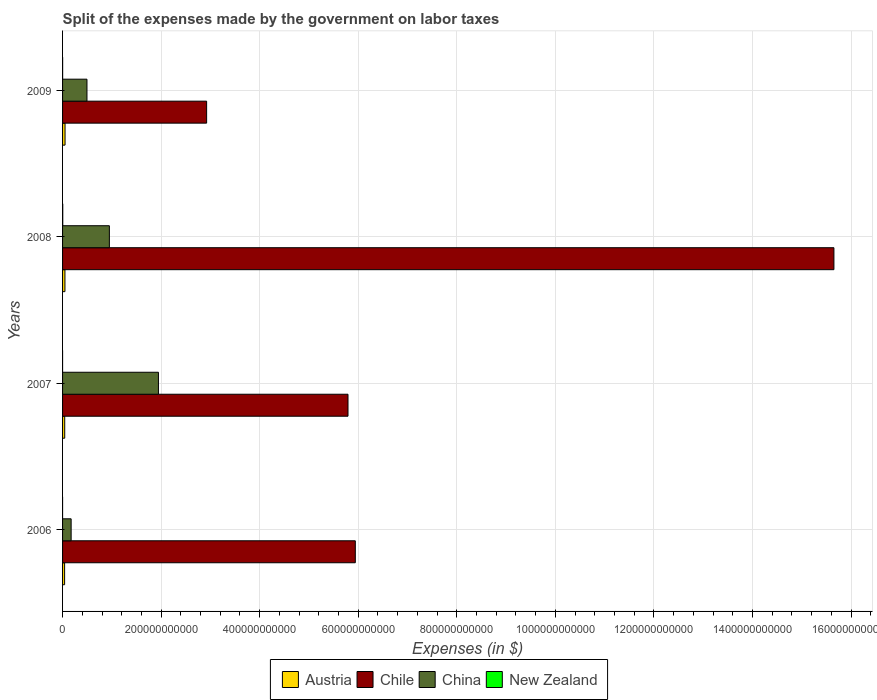How many different coloured bars are there?
Your answer should be very brief. 4. Are the number of bars per tick equal to the number of legend labels?
Your answer should be very brief. Yes. Are the number of bars on each tick of the Y-axis equal?
Your answer should be very brief. Yes. In how many cases, is the number of bars for a given year not equal to the number of legend labels?
Your answer should be compact. 0. What is the expenses made by the government on labor taxes in Chile in 2007?
Provide a short and direct response. 5.79e+11. Across all years, what is the maximum expenses made by the government on labor taxes in China?
Your answer should be very brief. 1.95e+11. Across all years, what is the minimum expenses made by the government on labor taxes in China?
Your answer should be very brief. 1.74e+1. In which year was the expenses made by the government on labor taxes in Chile maximum?
Your response must be concise. 2008. What is the total expenses made by the government on labor taxes in China in the graph?
Keep it short and to the point. 3.56e+11. What is the difference between the expenses made by the government on labor taxes in Austria in 2007 and that in 2008?
Provide a short and direct response. -4.27e+08. What is the difference between the expenses made by the government on labor taxes in Austria in 2008 and the expenses made by the government on labor taxes in Chile in 2007?
Provide a short and direct response. -5.74e+11. What is the average expenses made by the government on labor taxes in Austria per year?
Make the answer very short. 4.59e+09. In the year 2007, what is the difference between the expenses made by the government on labor taxes in Austria and expenses made by the government on labor taxes in China?
Your answer should be very brief. -1.90e+11. In how many years, is the expenses made by the government on labor taxes in China greater than 1440000000000 $?
Your response must be concise. 0. What is the ratio of the expenses made by the government on labor taxes in New Zealand in 2006 to that in 2008?
Offer a very short reply. 0.01. Is the difference between the expenses made by the government on labor taxes in Austria in 2008 and 2009 greater than the difference between the expenses made by the government on labor taxes in China in 2008 and 2009?
Keep it short and to the point. No. What is the difference between the highest and the second highest expenses made by the government on labor taxes in Austria?
Offer a terse response. 2.13e+08. What is the difference between the highest and the lowest expenses made by the government on labor taxes in Chile?
Give a very brief answer. 1.27e+12. Is the sum of the expenses made by the government on labor taxes in Chile in 2008 and 2009 greater than the maximum expenses made by the government on labor taxes in New Zealand across all years?
Give a very brief answer. Yes. Is it the case that in every year, the sum of the expenses made by the government on labor taxes in Austria and expenses made by the government on labor taxes in Chile is greater than the sum of expenses made by the government on labor taxes in New Zealand and expenses made by the government on labor taxes in China?
Give a very brief answer. Yes. What does the 4th bar from the top in 2007 represents?
Give a very brief answer. Austria. Is it the case that in every year, the sum of the expenses made by the government on labor taxes in Chile and expenses made by the government on labor taxes in China is greater than the expenses made by the government on labor taxes in New Zealand?
Provide a succinct answer. Yes. How many bars are there?
Your answer should be compact. 16. Are all the bars in the graph horizontal?
Your answer should be compact. Yes. How many years are there in the graph?
Offer a very short reply. 4. What is the difference between two consecutive major ticks on the X-axis?
Provide a succinct answer. 2.00e+11. Are the values on the major ticks of X-axis written in scientific E-notation?
Provide a short and direct response. No. Where does the legend appear in the graph?
Keep it short and to the point. Bottom center. How many legend labels are there?
Make the answer very short. 4. How are the legend labels stacked?
Make the answer very short. Horizontal. What is the title of the graph?
Ensure brevity in your answer.  Split of the expenses made by the government on labor taxes. Does "Congo (Republic)" appear as one of the legend labels in the graph?
Provide a short and direct response. No. What is the label or title of the X-axis?
Your answer should be compact. Expenses (in $). What is the label or title of the Y-axis?
Your answer should be compact. Years. What is the Expenses (in $) of Austria in 2006?
Make the answer very short. 4.15e+09. What is the Expenses (in $) of Chile in 2006?
Your response must be concise. 5.94e+11. What is the Expenses (in $) of China in 2006?
Keep it short and to the point. 1.74e+1. What is the Expenses (in $) in New Zealand in 2006?
Keep it short and to the point. 3.00e+06. What is the Expenses (in $) in Austria in 2007?
Ensure brevity in your answer.  4.38e+09. What is the Expenses (in $) of Chile in 2007?
Provide a succinct answer. 5.79e+11. What is the Expenses (in $) in China in 2007?
Give a very brief answer. 1.95e+11. What is the Expenses (in $) of Austria in 2008?
Ensure brevity in your answer.  4.81e+09. What is the Expenses (in $) of Chile in 2008?
Your response must be concise. 1.57e+12. What is the Expenses (in $) of China in 2008?
Provide a short and direct response. 9.50e+1. What is the Expenses (in $) in New Zealand in 2008?
Provide a succinct answer. 3.75e+08. What is the Expenses (in $) of Austria in 2009?
Offer a terse response. 5.02e+09. What is the Expenses (in $) in Chile in 2009?
Your response must be concise. 2.92e+11. What is the Expenses (in $) in China in 2009?
Provide a short and direct response. 4.95e+1. What is the Expenses (in $) of New Zealand in 2009?
Give a very brief answer. 1.28e+08. Across all years, what is the maximum Expenses (in $) in Austria?
Make the answer very short. 5.02e+09. Across all years, what is the maximum Expenses (in $) of Chile?
Offer a very short reply. 1.57e+12. Across all years, what is the maximum Expenses (in $) of China?
Your answer should be very brief. 1.95e+11. Across all years, what is the maximum Expenses (in $) in New Zealand?
Your answer should be very brief. 3.75e+08. Across all years, what is the minimum Expenses (in $) in Austria?
Give a very brief answer. 4.15e+09. Across all years, what is the minimum Expenses (in $) of Chile?
Your answer should be very brief. 2.92e+11. Across all years, what is the minimum Expenses (in $) in China?
Provide a short and direct response. 1.74e+1. What is the total Expenses (in $) of Austria in the graph?
Your answer should be compact. 1.84e+1. What is the total Expenses (in $) of Chile in the graph?
Give a very brief answer. 3.03e+12. What is the total Expenses (in $) in China in the graph?
Provide a short and direct response. 3.56e+11. What is the total Expenses (in $) in New Zealand in the graph?
Provide a succinct answer. 5.08e+08. What is the difference between the Expenses (in $) in Austria in 2006 and that in 2007?
Your answer should be very brief. -2.29e+08. What is the difference between the Expenses (in $) in Chile in 2006 and that in 2007?
Ensure brevity in your answer.  1.48e+1. What is the difference between the Expenses (in $) in China in 2006 and that in 2007?
Your response must be concise. -1.77e+11. What is the difference between the Expenses (in $) in New Zealand in 2006 and that in 2007?
Your answer should be very brief. 1.00e+06. What is the difference between the Expenses (in $) in Austria in 2006 and that in 2008?
Provide a succinct answer. -6.56e+08. What is the difference between the Expenses (in $) of Chile in 2006 and that in 2008?
Offer a terse response. -9.71e+11. What is the difference between the Expenses (in $) in China in 2006 and that in 2008?
Ensure brevity in your answer.  -7.76e+1. What is the difference between the Expenses (in $) in New Zealand in 2006 and that in 2008?
Offer a very short reply. -3.72e+08. What is the difference between the Expenses (in $) of Austria in 2006 and that in 2009?
Ensure brevity in your answer.  -8.69e+08. What is the difference between the Expenses (in $) in Chile in 2006 and that in 2009?
Provide a succinct answer. 3.02e+11. What is the difference between the Expenses (in $) of China in 2006 and that in 2009?
Your response must be concise. -3.21e+1. What is the difference between the Expenses (in $) of New Zealand in 2006 and that in 2009?
Give a very brief answer. -1.25e+08. What is the difference between the Expenses (in $) in Austria in 2007 and that in 2008?
Your response must be concise. -4.27e+08. What is the difference between the Expenses (in $) in Chile in 2007 and that in 2008?
Your answer should be compact. -9.86e+11. What is the difference between the Expenses (in $) of China in 2007 and that in 2008?
Keep it short and to the point. 9.95e+1. What is the difference between the Expenses (in $) of New Zealand in 2007 and that in 2008?
Your answer should be compact. -3.73e+08. What is the difference between the Expenses (in $) in Austria in 2007 and that in 2009?
Your response must be concise. -6.40e+08. What is the difference between the Expenses (in $) in Chile in 2007 and that in 2009?
Your answer should be compact. 2.87e+11. What is the difference between the Expenses (in $) in China in 2007 and that in 2009?
Offer a terse response. 1.45e+11. What is the difference between the Expenses (in $) in New Zealand in 2007 and that in 2009?
Provide a short and direct response. -1.26e+08. What is the difference between the Expenses (in $) of Austria in 2008 and that in 2009?
Make the answer very short. -2.13e+08. What is the difference between the Expenses (in $) in Chile in 2008 and that in 2009?
Your response must be concise. 1.27e+12. What is the difference between the Expenses (in $) in China in 2008 and that in 2009?
Offer a very short reply. 4.55e+1. What is the difference between the Expenses (in $) of New Zealand in 2008 and that in 2009?
Make the answer very short. 2.47e+08. What is the difference between the Expenses (in $) of Austria in 2006 and the Expenses (in $) of Chile in 2007?
Provide a short and direct response. -5.75e+11. What is the difference between the Expenses (in $) in Austria in 2006 and the Expenses (in $) in China in 2007?
Offer a terse response. -1.90e+11. What is the difference between the Expenses (in $) in Austria in 2006 and the Expenses (in $) in New Zealand in 2007?
Keep it short and to the point. 4.15e+09. What is the difference between the Expenses (in $) of Chile in 2006 and the Expenses (in $) of China in 2007?
Provide a succinct answer. 3.99e+11. What is the difference between the Expenses (in $) in Chile in 2006 and the Expenses (in $) in New Zealand in 2007?
Keep it short and to the point. 5.94e+11. What is the difference between the Expenses (in $) in China in 2006 and the Expenses (in $) in New Zealand in 2007?
Offer a terse response. 1.74e+1. What is the difference between the Expenses (in $) in Austria in 2006 and the Expenses (in $) in Chile in 2008?
Give a very brief answer. -1.56e+12. What is the difference between the Expenses (in $) of Austria in 2006 and the Expenses (in $) of China in 2008?
Make the answer very short. -9.08e+1. What is the difference between the Expenses (in $) of Austria in 2006 and the Expenses (in $) of New Zealand in 2008?
Keep it short and to the point. 3.78e+09. What is the difference between the Expenses (in $) of Chile in 2006 and the Expenses (in $) of China in 2008?
Ensure brevity in your answer.  4.99e+11. What is the difference between the Expenses (in $) of Chile in 2006 and the Expenses (in $) of New Zealand in 2008?
Make the answer very short. 5.94e+11. What is the difference between the Expenses (in $) of China in 2006 and the Expenses (in $) of New Zealand in 2008?
Provide a short and direct response. 1.70e+1. What is the difference between the Expenses (in $) of Austria in 2006 and the Expenses (in $) of Chile in 2009?
Keep it short and to the point. -2.88e+11. What is the difference between the Expenses (in $) in Austria in 2006 and the Expenses (in $) in China in 2009?
Your response must be concise. -4.54e+1. What is the difference between the Expenses (in $) of Austria in 2006 and the Expenses (in $) of New Zealand in 2009?
Your response must be concise. 4.02e+09. What is the difference between the Expenses (in $) in Chile in 2006 and the Expenses (in $) in China in 2009?
Provide a short and direct response. 5.44e+11. What is the difference between the Expenses (in $) of Chile in 2006 and the Expenses (in $) of New Zealand in 2009?
Your response must be concise. 5.94e+11. What is the difference between the Expenses (in $) of China in 2006 and the Expenses (in $) of New Zealand in 2009?
Your answer should be compact. 1.73e+1. What is the difference between the Expenses (in $) of Austria in 2007 and the Expenses (in $) of Chile in 2008?
Your answer should be very brief. -1.56e+12. What is the difference between the Expenses (in $) of Austria in 2007 and the Expenses (in $) of China in 2008?
Offer a very short reply. -9.06e+1. What is the difference between the Expenses (in $) in Austria in 2007 and the Expenses (in $) in New Zealand in 2008?
Keep it short and to the point. 4.00e+09. What is the difference between the Expenses (in $) of Chile in 2007 and the Expenses (in $) of China in 2008?
Ensure brevity in your answer.  4.84e+11. What is the difference between the Expenses (in $) in Chile in 2007 and the Expenses (in $) in New Zealand in 2008?
Your response must be concise. 5.79e+11. What is the difference between the Expenses (in $) in China in 2007 and the Expenses (in $) in New Zealand in 2008?
Your response must be concise. 1.94e+11. What is the difference between the Expenses (in $) in Austria in 2007 and the Expenses (in $) in Chile in 2009?
Keep it short and to the point. -2.88e+11. What is the difference between the Expenses (in $) in Austria in 2007 and the Expenses (in $) in China in 2009?
Your response must be concise. -4.51e+1. What is the difference between the Expenses (in $) in Austria in 2007 and the Expenses (in $) in New Zealand in 2009?
Ensure brevity in your answer.  4.25e+09. What is the difference between the Expenses (in $) of Chile in 2007 and the Expenses (in $) of China in 2009?
Your answer should be compact. 5.30e+11. What is the difference between the Expenses (in $) of Chile in 2007 and the Expenses (in $) of New Zealand in 2009?
Give a very brief answer. 5.79e+11. What is the difference between the Expenses (in $) in China in 2007 and the Expenses (in $) in New Zealand in 2009?
Provide a short and direct response. 1.94e+11. What is the difference between the Expenses (in $) of Austria in 2008 and the Expenses (in $) of Chile in 2009?
Offer a very short reply. -2.87e+11. What is the difference between the Expenses (in $) of Austria in 2008 and the Expenses (in $) of China in 2009?
Make the answer very short. -4.47e+1. What is the difference between the Expenses (in $) in Austria in 2008 and the Expenses (in $) in New Zealand in 2009?
Offer a terse response. 4.68e+09. What is the difference between the Expenses (in $) in Chile in 2008 and the Expenses (in $) in China in 2009?
Offer a very short reply. 1.52e+12. What is the difference between the Expenses (in $) of Chile in 2008 and the Expenses (in $) of New Zealand in 2009?
Keep it short and to the point. 1.56e+12. What is the difference between the Expenses (in $) of China in 2008 and the Expenses (in $) of New Zealand in 2009?
Give a very brief answer. 9.49e+1. What is the average Expenses (in $) of Austria per year?
Your answer should be compact. 4.59e+09. What is the average Expenses (in $) in Chile per year?
Your response must be concise. 7.58e+11. What is the average Expenses (in $) of China per year?
Keep it short and to the point. 8.91e+1. What is the average Expenses (in $) in New Zealand per year?
Offer a terse response. 1.27e+08. In the year 2006, what is the difference between the Expenses (in $) in Austria and Expenses (in $) in Chile?
Your response must be concise. -5.90e+11. In the year 2006, what is the difference between the Expenses (in $) in Austria and Expenses (in $) in China?
Your answer should be very brief. -1.33e+1. In the year 2006, what is the difference between the Expenses (in $) of Austria and Expenses (in $) of New Zealand?
Give a very brief answer. 4.15e+09. In the year 2006, what is the difference between the Expenses (in $) of Chile and Expenses (in $) of China?
Give a very brief answer. 5.77e+11. In the year 2006, what is the difference between the Expenses (in $) in Chile and Expenses (in $) in New Zealand?
Your answer should be very brief. 5.94e+11. In the year 2006, what is the difference between the Expenses (in $) in China and Expenses (in $) in New Zealand?
Ensure brevity in your answer.  1.74e+1. In the year 2007, what is the difference between the Expenses (in $) of Austria and Expenses (in $) of Chile?
Your answer should be very brief. -5.75e+11. In the year 2007, what is the difference between the Expenses (in $) of Austria and Expenses (in $) of China?
Offer a terse response. -1.90e+11. In the year 2007, what is the difference between the Expenses (in $) of Austria and Expenses (in $) of New Zealand?
Offer a very short reply. 4.38e+09. In the year 2007, what is the difference between the Expenses (in $) in Chile and Expenses (in $) in China?
Provide a succinct answer. 3.85e+11. In the year 2007, what is the difference between the Expenses (in $) of Chile and Expenses (in $) of New Zealand?
Give a very brief answer. 5.79e+11. In the year 2007, what is the difference between the Expenses (in $) of China and Expenses (in $) of New Zealand?
Give a very brief answer. 1.95e+11. In the year 2008, what is the difference between the Expenses (in $) in Austria and Expenses (in $) in Chile?
Provide a short and direct response. -1.56e+12. In the year 2008, what is the difference between the Expenses (in $) in Austria and Expenses (in $) in China?
Provide a succinct answer. -9.02e+1. In the year 2008, what is the difference between the Expenses (in $) of Austria and Expenses (in $) of New Zealand?
Provide a succinct answer. 4.43e+09. In the year 2008, what is the difference between the Expenses (in $) in Chile and Expenses (in $) in China?
Your answer should be very brief. 1.47e+12. In the year 2008, what is the difference between the Expenses (in $) in Chile and Expenses (in $) in New Zealand?
Your answer should be compact. 1.56e+12. In the year 2008, what is the difference between the Expenses (in $) in China and Expenses (in $) in New Zealand?
Make the answer very short. 9.46e+1. In the year 2009, what is the difference between the Expenses (in $) of Austria and Expenses (in $) of Chile?
Provide a succinct answer. -2.87e+11. In the year 2009, what is the difference between the Expenses (in $) in Austria and Expenses (in $) in China?
Offer a terse response. -4.45e+1. In the year 2009, what is the difference between the Expenses (in $) of Austria and Expenses (in $) of New Zealand?
Provide a succinct answer. 4.89e+09. In the year 2009, what is the difference between the Expenses (in $) of Chile and Expenses (in $) of China?
Offer a very short reply. 2.43e+11. In the year 2009, what is the difference between the Expenses (in $) in Chile and Expenses (in $) in New Zealand?
Provide a short and direct response. 2.92e+11. In the year 2009, what is the difference between the Expenses (in $) in China and Expenses (in $) in New Zealand?
Your answer should be compact. 4.94e+1. What is the ratio of the Expenses (in $) of Austria in 2006 to that in 2007?
Offer a terse response. 0.95. What is the ratio of the Expenses (in $) in Chile in 2006 to that in 2007?
Your answer should be compact. 1.03. What is the ratio of the Expenses (in $) in China in 2006 to that in 2007?
Offer a very short reply. 0.09. What is the ratio of the Expenses (in $) in Austria in 2006 to that in 2008?
Give a very brief answer. 0.86. What is the ratio of the Expenses (in $) of Chile in 2006 to that in 2008?
Keep it short and to the point. 0.38. What is the ratio of the Expenses (in $) of China in 2006 to that in 2008?
Offer a very short reply. 0.18. What is the ratio of the Expenses (in $) of New Zealand in 2006 to that in 2008?
Offer a terse response. 0.01. What is the ratio of the Expenses (in $) of Austria in 2006 to that in 2009?
Offer a terse response. 0.83. What is the ratio of the Expenses (in $) of Chile in 2006 to that in 2009?
Keep it short and to the point. 2.03. What is the ratio of the Expenses (in $) in China in 2006 to that in 2009?
Provide a short and direct response. 0.35. What is the ratio of the Expenses (in $) of New Zealand in 2006 to that in 2009?
Your response must be concise. 0.02. What is the ratio of the Expenses (in $) of Austria in 2007 to that in 2008?
Your response must be concise. 0.91. What is the ratio of the Expenses (in $) of Chile in 2007 to that in 2008?
Offer a very short reply. 0.37. What is the ratio of the Expenses (in $) in China in 2007 to that in 2008?
Keep it short and to the point. 2.05. What is the ratio of the Expenses (in $) of New Zealand in 2007 to that in 2008?
Offer a terse response. 0.01. What is the ratio of the Expenses (in $) in Austria in 2007 to that in 2009?
Provide a short and direct response. 0.87. What is the ratio of the Expenses (in $) in Chile in 2007 to that in 2009?
Keep it short and to the point. 1.98. What is the ratio of the Expenses (in $) of China in 2007 to that in 2009?
Provide a succinct answer. 3.93. What is the ratio of the Expenses (in $) of New Zealand in 2007 to that in 2009?
Provide a succinct answer. 0.02. What is the ratio of the Expenses (in $) in Austria in 2008 to that in 2009?
Provide a short and direct response. 0.96. What is the ratio of the Expenses (in $) in Chile in 2008 to that in 2009?
Ensure brevity in your answer.  5.35. What is the ratio of the Expenses (in $) of China in 2008 to that in 2009?
Offer a very short reply. 1.92. What is the ratio of the Expenses (in $) of New Zealand in 2008 to that in 2009?
Provide a succinct answer. 2.93. What is the difference between the highest and the second highest Expenses (in $) of Austria?
Provide a short and direct response. 2.13e+08. What is the difference between the highest and the second highest Expenses (in $) of Chile?
Ensure brevity in your answer.  9.71e+11. What is the difference between the highest and the second highest Expenses (in $) of China?
Provide a succinct answer. 9.95e+1. What is the difference between the highest and the second highest Expenses (in $) in New Zealand?
Your answer should be very brief. 2.47e+08. What is the difference between the highest and the lowest Expenses (in $) of Austria?
Give a very brief answer. 8.69e+08. What is the difference between the highest and the lowest Expenses (in $) of Chile?
Provide a succinct answer. 1.27e+12. What is the difference between the highest and the lowest Expenses (in $) of China?
Give a very brief answer. 1.77e+11. What is the difference between the highest and the lowest Expenses (in $) in New Zealand?
Provide a short and direct response. 3.73e+08. 